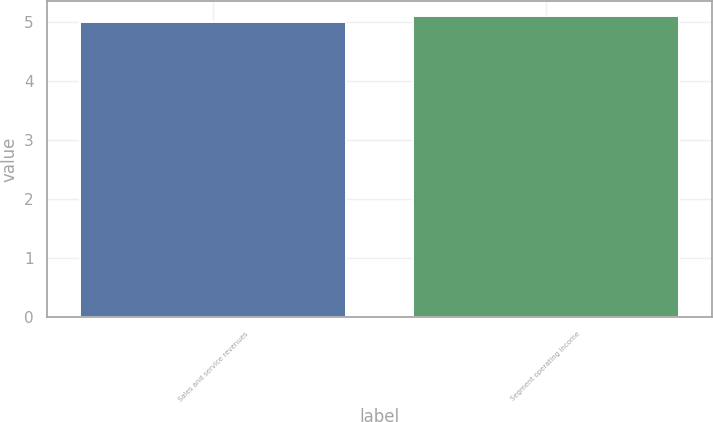<chart> <loc_0><loc_0><loc_500><loc_500><bar_chart><fcel>Sales and service revenues<fcel>Segment operating income<nl><fcel>5<fcel>5.1<nl></chart> 